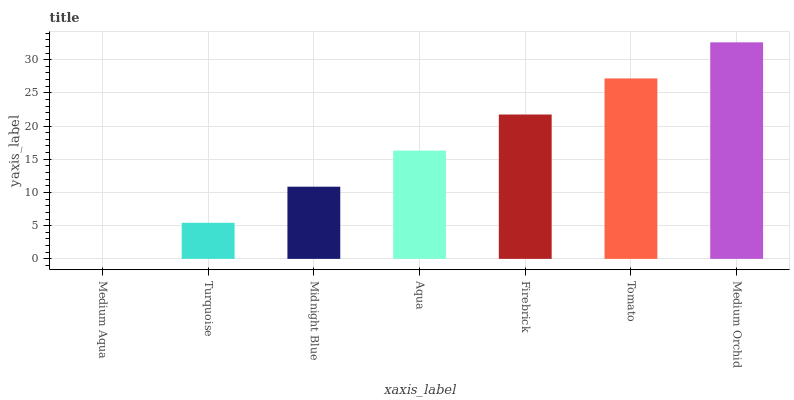Is Turquoise the minimum?
Answer yes or no. No. Is Turquoise the maximum?
Answer yes or no. No. Is Turquoise greater than Medium Aqua?
Answer yes or no. Yes. Is Medium Aqua less than Turquoise?
Answer yes or no. Yes. Is Medium Aqua greater than Turquoise?
Answer yes or no. No. Is Turquoise less than Medium Aqua?
Answer yes or no. No. Is Aqua the high median?
Answer yes or no. Yes. Is Aqua the low median?
Answer yes or no. Yes. Is Midnight Blue the high median?
Answer yes or no. No. Is Medium Aqua the low median?
Answer yes or no. No. 